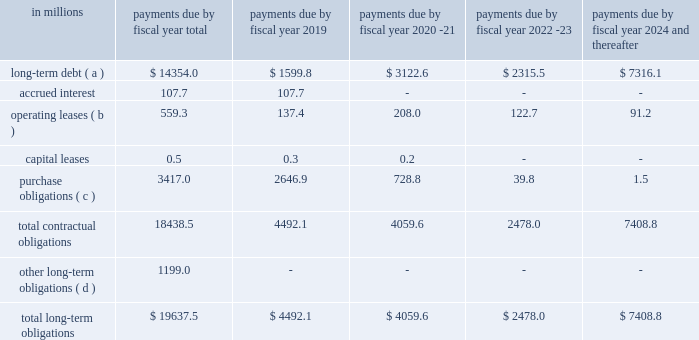Obligations of non-consolidated affiliates , mainly cpw .
In addition , off-balance sheet arrangements are generally limited to the future payments under non-cancelable operating leases , which totaled $ 559 million as of may 27 , as of may 27 , 2018 , we had invested in five variable interest entities ( vies ) .
None of our vies are material to our results of operations , financial condition , or liquidity as of and for the fiscal year ended may 27 , 2018 .
Our defined benefit plans in the united states are subject to the requirements of the pension protection act ( ppa ) .
In the future , the ppa may require us to make additional contributions to our domestic plans .
We do not expect to be required to make any contributions in fiscal 2019 .
The table summarizes our future estimated cash payments under existing contractual obligations , including payments due by period: .
( a ) amounts represent the expected cash payments of our long-term debt and do not include $ 0.5 million for capital leases or $ 85.7 million for net unamortized debt issuance costs , premiums and discounts , and fair value adjustments .
( b ) operating leases represents the minimum rental commitments under non-cancelable operating leases .
( c ) the majority of the purchase obligations represent commitments for raw material and packaging to be utilized in the normal course of business and for consumer marketing spending commitments that support our brands .
For purposes of this table , arrangements are considered purchase obligations if a contract specifies all significant terms , including fixed or minimum quantities to be purchased , a pricing structure , and approximate timing of the transaction .
Most arrangements are cancelable without a significant penalty and with short notice ( usually 30 days ) .
Any amounts reflected on the consolidated balance sheets as accounts payable and accrued liabilities are excluded from the table above .
( d ) the fair value of our foreign exchange , equity , commodity , and grain derivative contracts with a payable position to the counterparty was $ 16 million as of may 27 , 2018 , based on fair market values as of that date .
Future changes in market values will impact the amount of cash ultimately paid or received to settle those instruments in the future .
Other long-term obligations mainly consist of liabilities for accrued compensation and benefits , including the underfunded status of certain of our defined benefit pension , other postretirement benefit , and postemployment benefit plans , and miscellaneous liabilities .
We expect to pay $ 20 million of benefits from our unfunded postemployment benefit plans and $ 18 million of deferred compensation in fiscal 2019 .
We are unable to reliably estimate the amount of these payments beyond fiscal 2019 .
As of may 27 , 2018 , our total liability for uncertain tax positions and accrued interest and penalties was $ 223.6 million .
Significant accounting estimates for a complete description of our significant accounting policies , please see note 2 to the consolidated financial statements in item 8 of this report .
Our significant accounting estimates are those that have a meaningful impact .
What is the percent of the future estimated cash payments under existing contractual obligations that was due in 2019 for long-term debt? 
Computations: (1599.8 / 14354.0)
Answer: 0.11145. Obligations of non-consolidated affiliates , mainly cpw .
In addition , off-balance sheet arrangements are generally limited to the future payments under non-cancelable operating leases , which totaled $ 559 million as of may 27 , as of may 27 , 2018 , we had invested in five variable interest entities ( vies ) .
None of our vies are material to our results of operations , financial condition , or liquidity as of and for the fiscal year ended may 27 , 2018 .
Our defined benefit plans in the united states are subject to the requirements of the pension protection act ( ppa ) .
In the future , the ppa may require us to make additional contributions to our domestic plans .
We do not expect to be required to make any contributions in fiscal 2019 .
The table summarizes our future estimated cash payments under existing contractual obligations , including payments due by period: .
( a ) amounts represent the expected cash payments of our long-term debt and do not include $ 0.5 million for capital leases or $ 85.7 million for net unamortized debt issuance costs , premiums and discounts , and fair value adjustments .
( b ) operating leases represents the minimum rental commitments under non-cancelable operating leases .
( c ) the majority of the purchase obligations represent commitments for raw material and packaging to be utilized in the normal course of business and for consumer marketing spending commitments that support our brands .
For purposes of this table , arrangements are considered purchase obligations if a contract specifies all significant terms , including fixed or minimum quantities to be purchased , a pricing structure , and approximate timing of the transaction .
Most arrangements are cancelable without a significant penalty and with short notice ( usually 30 days ) .
Any amounts reflected on the consolidated balance sheets as accounts payable and accrued liabilities are excluded from the table above .
( d ) the fair value of our foreign exchange , equity , commodity , and grain derivative contracts with a payable position to the counterparty was $ 16 million as of may 27 , 2018 , based on fair market values as of that date .
Future changes in market values will impact the amount of cash ultimately paid or received to settle those instruments in the future .
Other long-term obligations mainly consist of liabilities for accrued compensation and benefits , including the underfunded status of certain of our defined benefit pension , other postretirement benefit , and postemployment benefit plans , and miscellaneous liabilities .
We expect to pay $ 20 million of benefits from our unfunded postemployment benefit plans and $ 18 million of deferred compensation in fiscal 2019 .
We are unable to reliably estimate the amount of these payments beyond fiscal 2019 .
As of may 27 , 2018 , our total liability for uncertain tax positions and accrued interest and penalties was $ 223.6 million .
Significant accounting estimates for a complete description of our significant accounting policies , please see note 2 to the consolidated financial statements in item 8 of this report .
Our significant accounting estimates are those that have a meaningful impact .
What percent of total long-term obligations is incurred by operating leases? 
Computations: (559.3 / 19637.5)
Answer: 0.02848. 